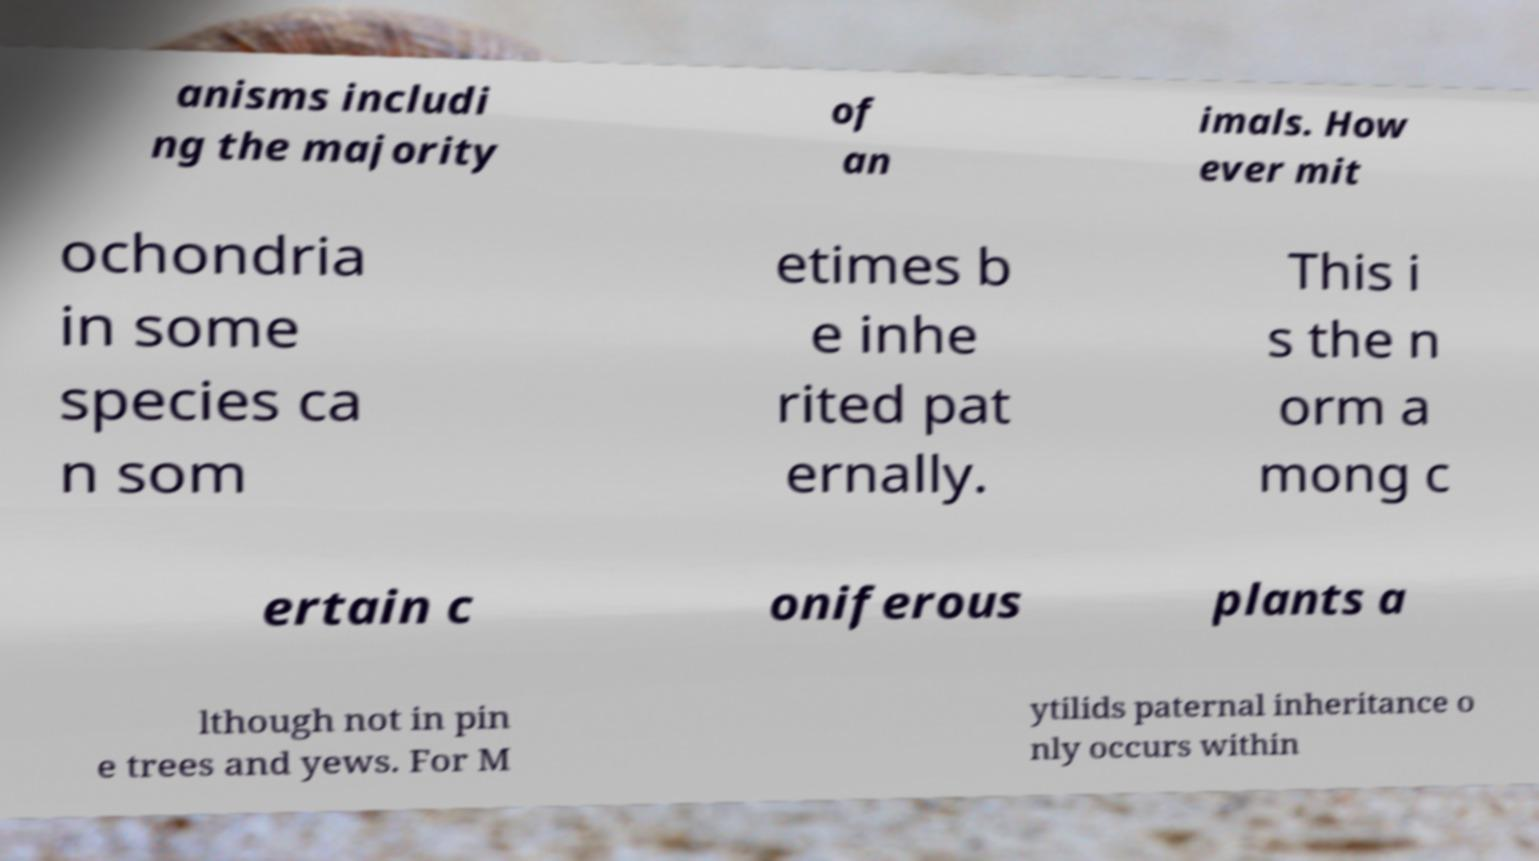Can you read and provide the text displayed in the image?This photo seems to have some interesting text. Can you extract and type it out for me? anisms includi ng the majority of an imals. How ever mit ochondria in some species ca n som etimes b e inhe rited pat ernally. This i s the n orm a mong c ertain c oniferous plants a lthough not in pin e trees and yews. For M ytilids paternal inheritance o nly occurs within 